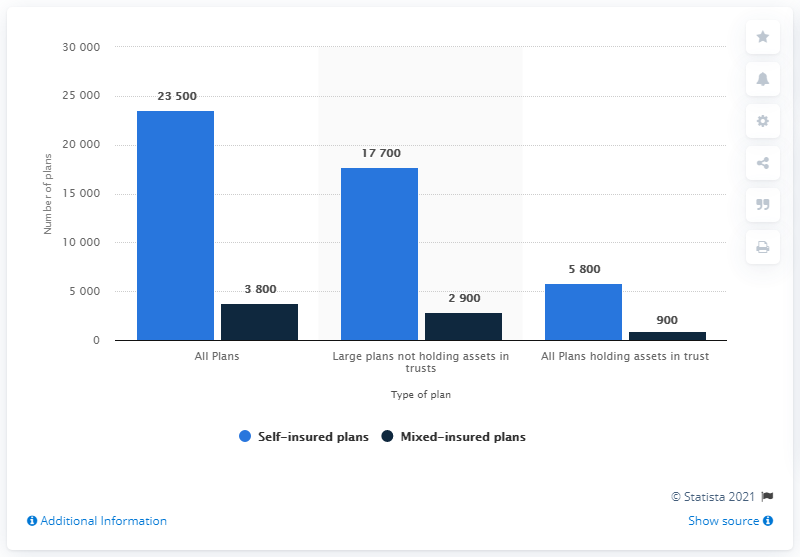Highlight a few significant elements in this photo. The average of self-insured plans and mixed-insured plans should be summed up to an amount of 18,200. 